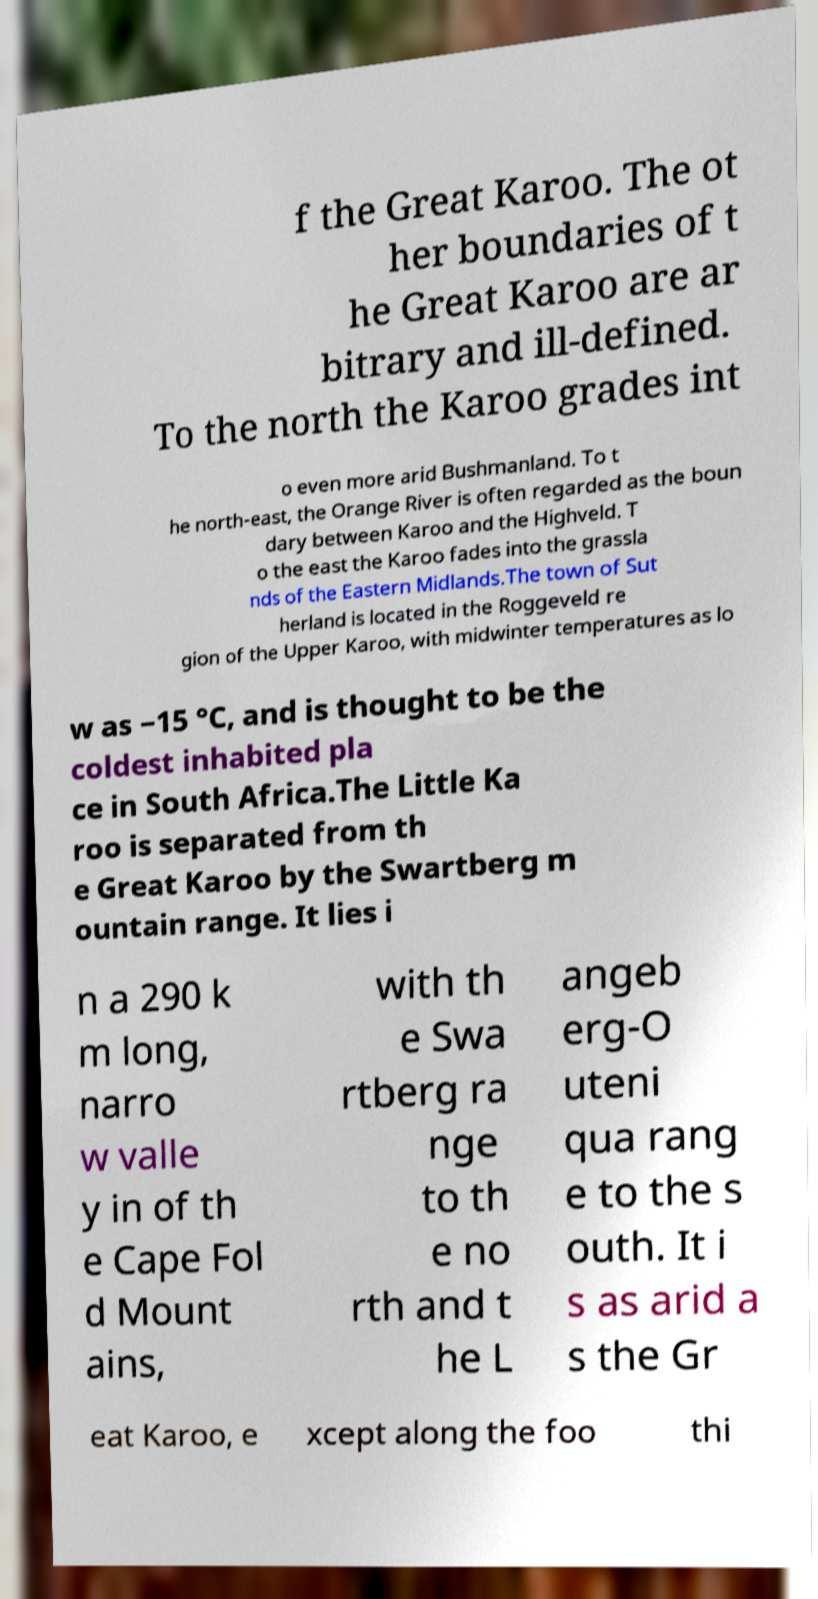Can you read and provide the text displayed in the image?This photo seems to have some interesting text. Can you extract and type it out for me? f the Great Karoo. The ot her boundaries of t he Great Karoo are ar bitrary and ill-defined. To the north the Karoo grades int o even more arid Bushmanland. To t he north-east, the Orange River is often regarded as the boun dary between Karoo and the Highveld. T o the east the Karoo fades into the grassla nds of the Eastern Midlands.The town of Sut herland is located in the Roggeveld re gion of the Upper Karoo, with midwinter temperatures as lo w as −15 °C, and is thought to be the coldest inhabited pla ce in South Africa.The Little Ka roo is separated from th e Great Karoo by the Swartberg m ountain range. It lies i n a 290 k m long, narro w valle y in of th e Cape Fol d Mount ains, with th e Swa rtberg ra nge to th e no rth and t he L angeb erg-O uteni qua rang e to the s outh. It i s as arid a s the Gr eat Karoo, e xcept along the foo thi 